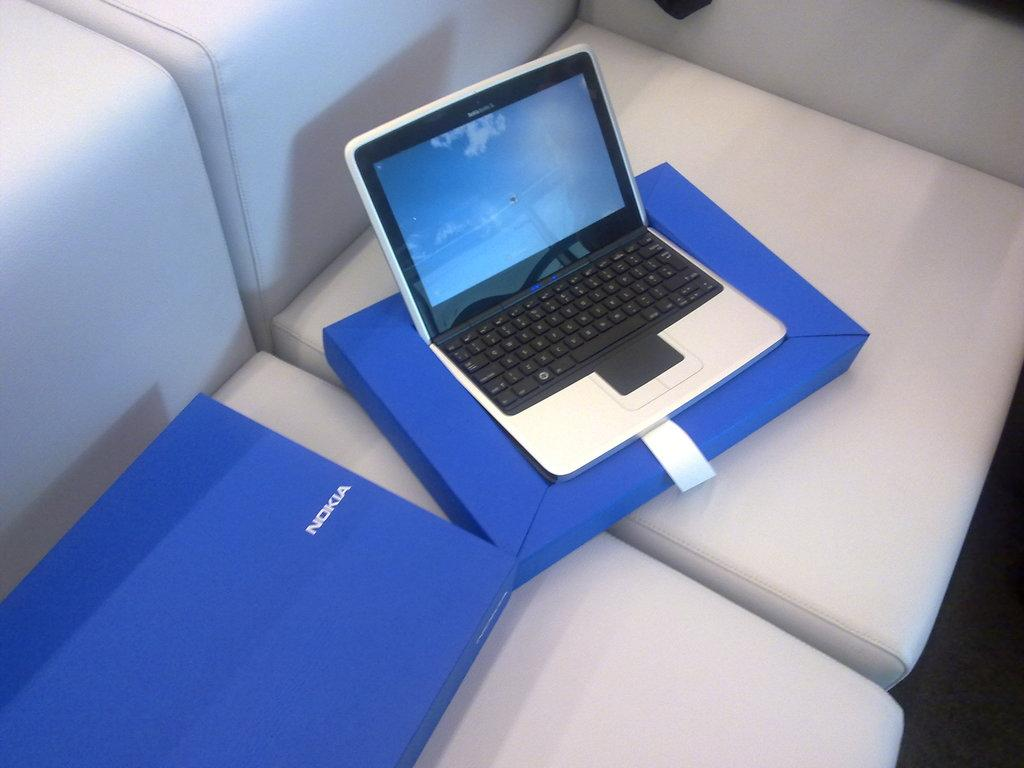<image>
Summarize the visual content of the image. A chair has a laptop it is sitting on a blue box the blue box next to it says Nokia 